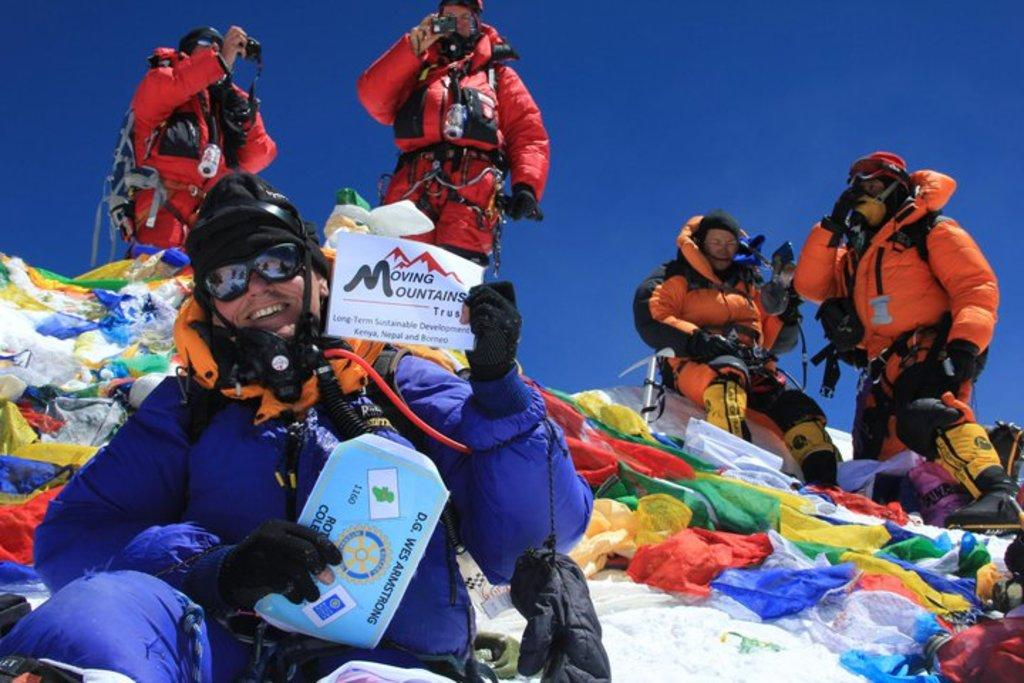How many people are in the image? There are 5 people in the image. What colors are the dresses worn by the people? The people are wearing blue, orange, and red dresses. What is the person at the front holding? The person at the front is holding 2 papers. What can be seen behind the person at the front? There are colorful items visible behind the person at the front. What is visible at the top of the image? The sky is visible at the top of the image. Can you tell me how many frogs are sitting on the person's head in the image? There are no frogs present in the image; the people are wearing dresses. What type of comb is being used by the person in the orange dress? There is no comb visible in the image, as the people are wearing dresses and not combing their hair. 